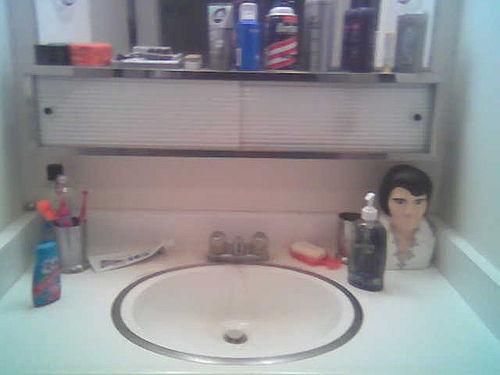Which celebrity do you see?
Quick response, please. Elvis. Is the sink full?
Write a very short answer. No. Is the faucet working?
Keep it brief. Yes. How can you tell a man is likely to use this sink?
Concise answer only. Shaving cream. 